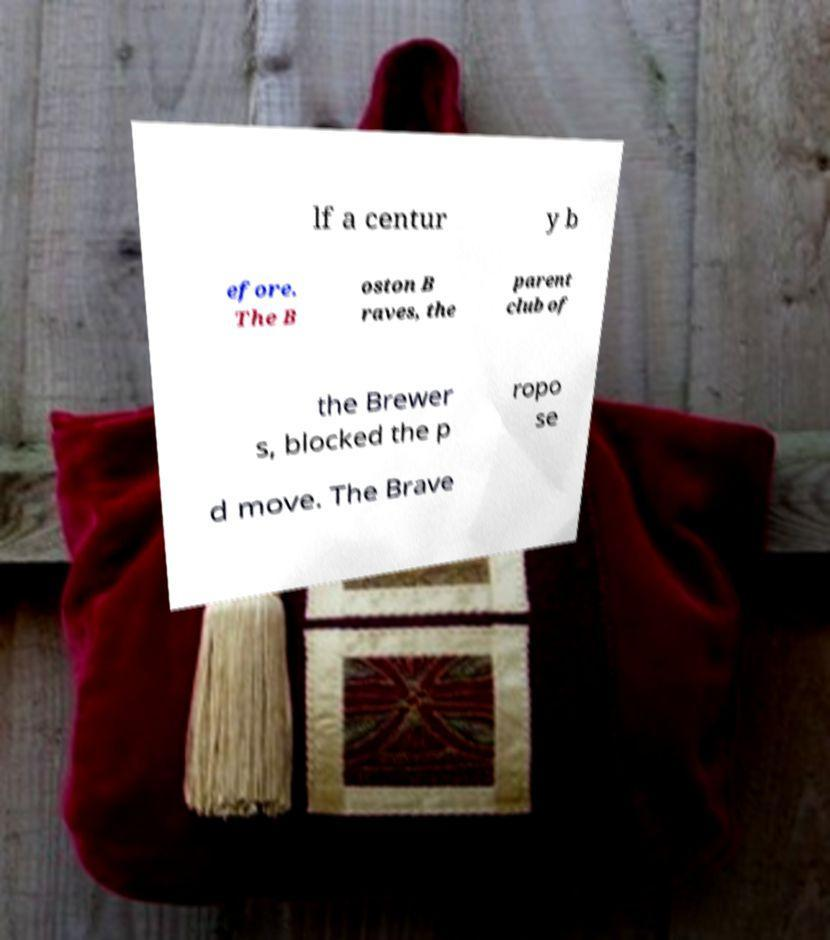There's text embedded in this image that I need extracted. Can you transcribe it verbatim? lf a centur y b efore. The B oston B raves, the parent club of the Brewer s, blocked the p ropo se d move. The Brave 